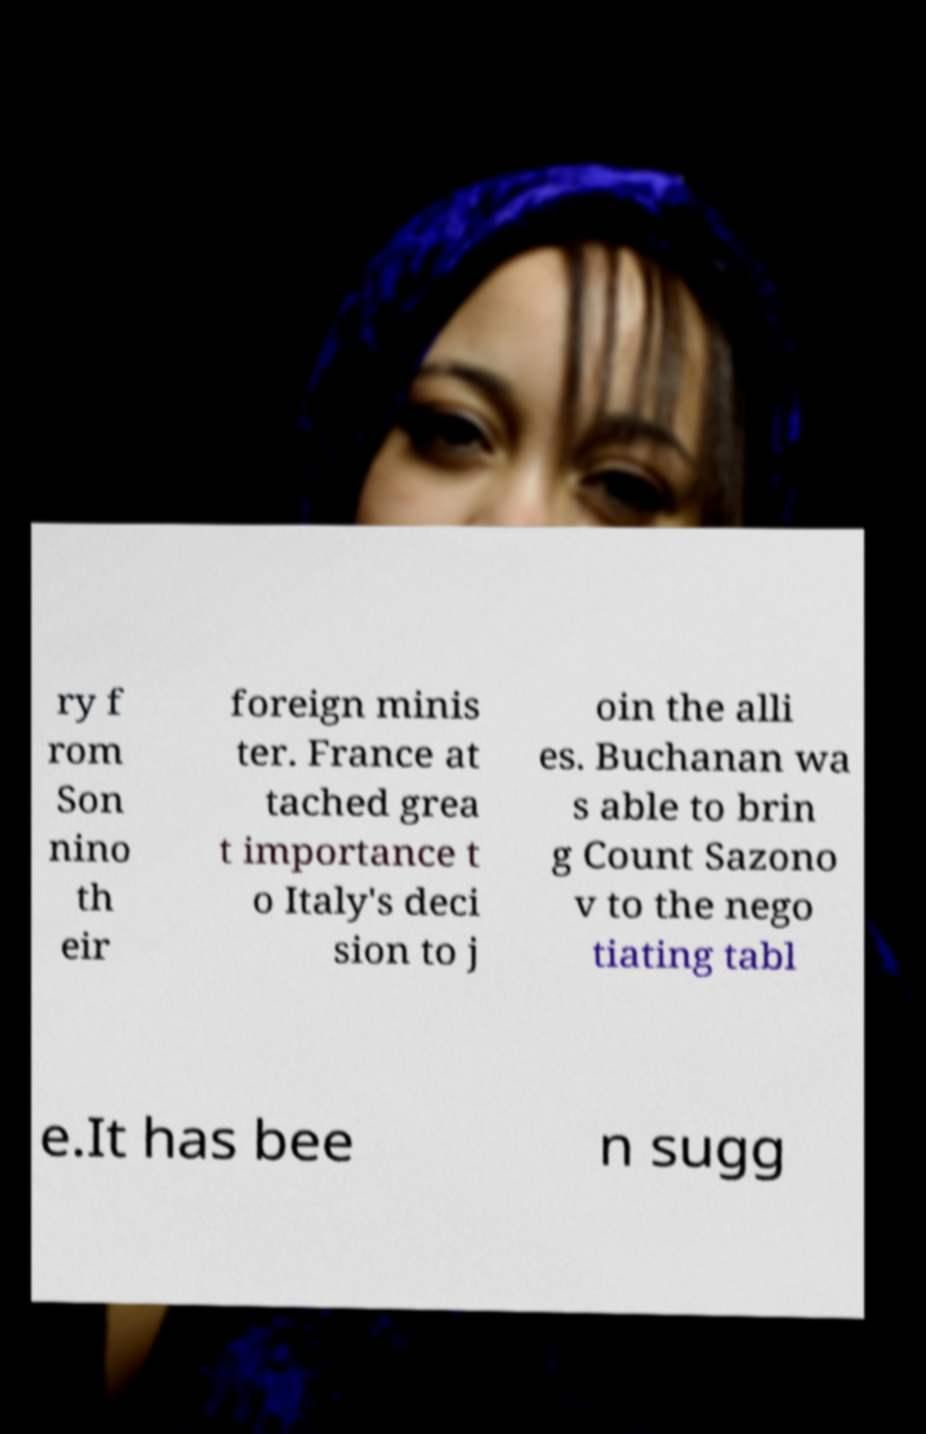Could you extract and type out the text from this image? ry f rom Son nino th eir foreign minis ter. France at tached grea t importance t o Italy's deci sion to j oin the alli es. Buchanan wa s able to brin g Count Sazono v to the nego tiating tabl e.It has bee n sugg 